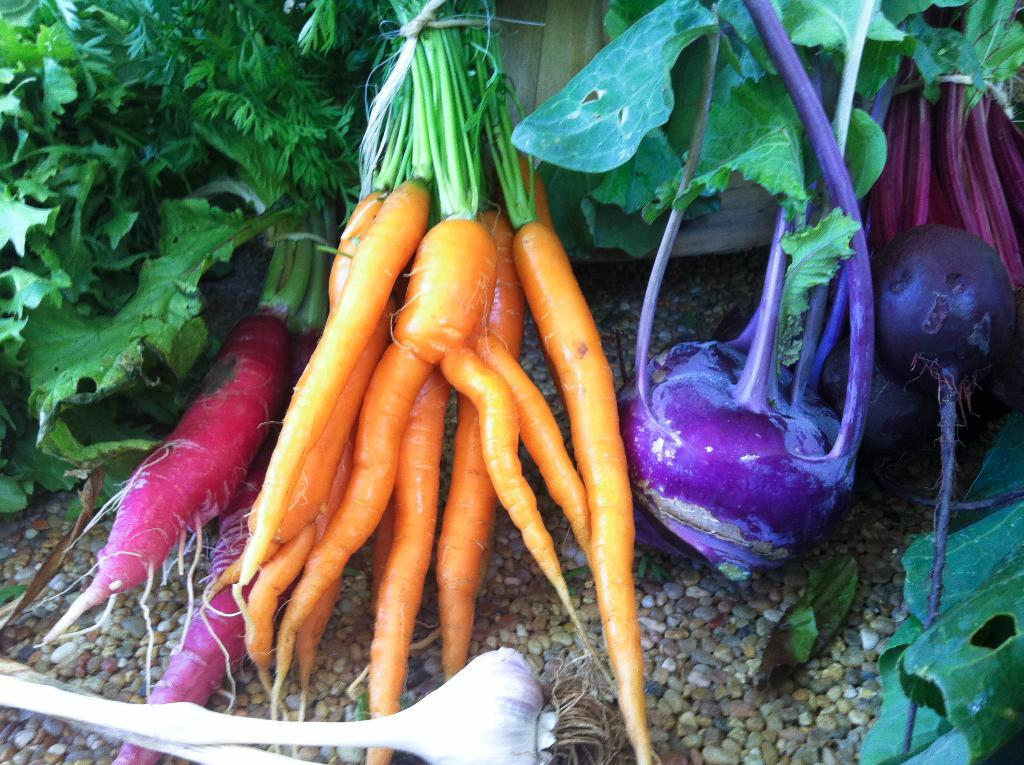What type of food can be seen in the image? There are vegetables in the image. What arithmetic problem is being solved by the ghost on the skate in the image? There is no ghost or skate present in the image, and therefore no arithmetic problem being solved. 